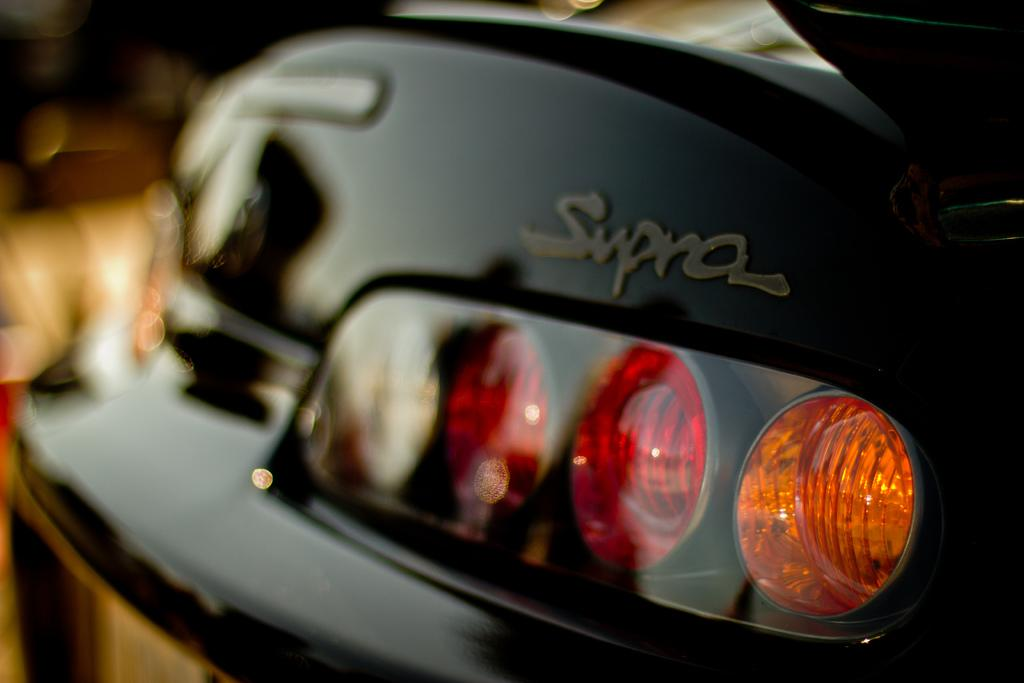What is the main object in the image? The main object in the image is the headlight of a car. Are there any additional lights associated with the headlight? Yes, there are four small lights associated with the headlight. What type of oranges can be seen rolling near the headlight in the image? There are no oranges present in the image, and therefore no such activity can be observed. 